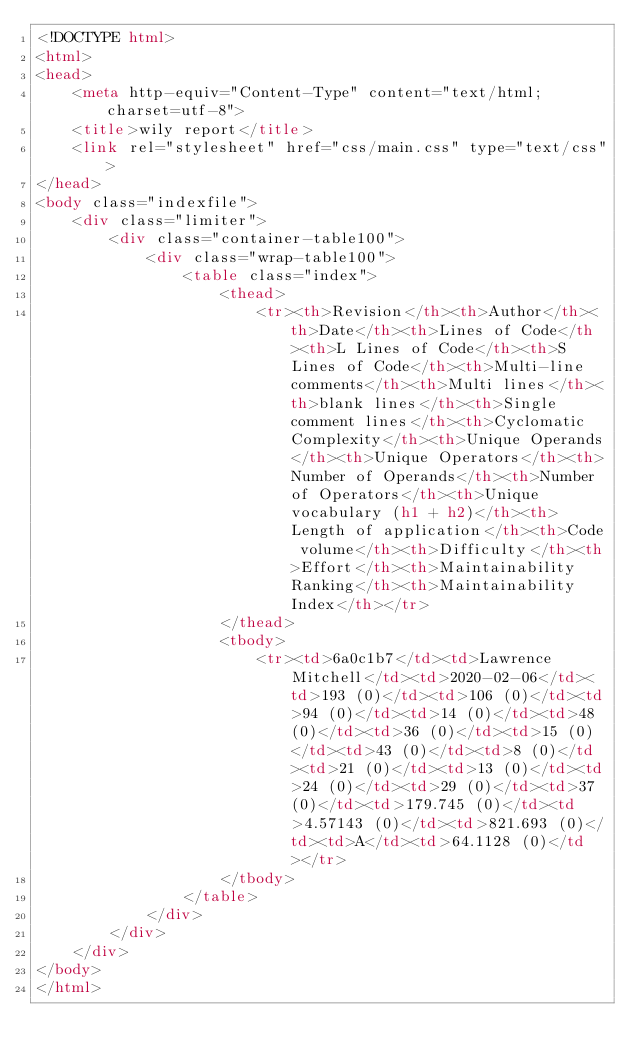<code> <loc_0><loc_0><loc_500><loc_500><_HTML_><!DOCTYPE html>
<html>
<head>
    <meta http-equiv="Content-Type" content="text/html; charset=utf-8">
    <title>wily report</title>
    <link rel="stylesheet" href="css/main.css" type="text/css">
</head>
<body class="indexfile">
    <div class="limiter">
		<div class="container-table100">
			<div class="wrap-table100">
                <table class="index">
                    <thead>
                        <tr><th>Revision</th><th>Author</th><th>Date</th><th>Lines of Code</th><th>L Lines of Code</th><th>S Lines of Code</th><th>Multi-line comments</th><th>Multi lines</th><th>blank lines</th><th>Single comment lines</th><th>Cyclomatic Complexity</th><th>Unique Operands</th><th>Unique Operators</th><th>Number of Operands</th><th>Number of Operators</th><th>Unique vocabulary (h1 + h2)</th><th>Length of application</th><th>Code volume</th><th>Difficulty</th><th>Effort</th><th>Maintainability Ranking</th><th>Maintainability Index</th></tr>
                    </thead>
                    <tbody>
                        <tr><td>6a0c1b7</td><td>Lawrence Mitchell</td><td>2020-02-06</td><td>193 (0)</td><td>106 (0)</td><td>94 (0)</td><td>14 (0)</td><td>48 (0)</td><td>36 (0)</td><td>15 (0)</td><td>43 (0)</td><td>8 (0)</td><td>21 (0)</td><td>13 (0)</td><td>24 (0)</td><td>29 (0)</td><td>37 (0)</td><td>179.745 (0)</td><td>4.57143 (0)</td><td>821.693 (0)</td><td>A</td><td>64.1128 (0)</td></tr>
                    </tbody>
                </table>
            </div>
        </div>
    </div>
</body>
</html></code> 